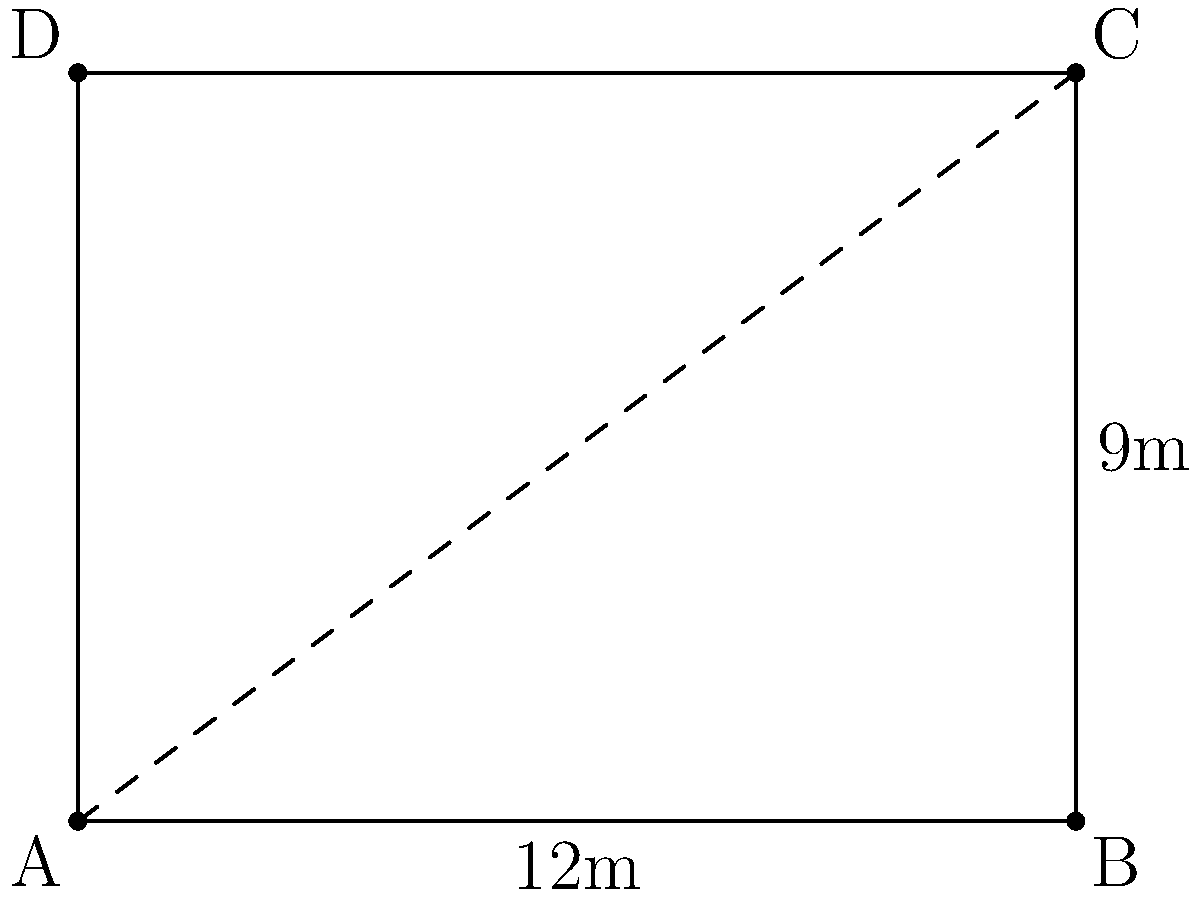In a rectangular dojo, two martial artists stand at opposite corners. The dojo measures 12 meters in length and 9 meters in width. What is the distance between the two martial artists? To find the distance between the two martial artists standing at opposite corners of the rectangular dojo, we can use the Pythagorean theorem. Let's approach this step-by-step:

1) The dojo forms a rectangle with length 12 meters and width 9 meters.

2) The distance between the opposite corners forms the hypotenuse of a right triangle.

3) Let's call this distance $d$. According to the Pythagorean theorem:

   $d^2 = 12^2 + 9^2$

4) Simplify the right side:
   $d^2 = 144 + 81 = 225$

5) Take the square root of both sides:
   $d = \sqrt{225}$

6) Simplify:
   $d = 15$

Therefore, the distance between the two martial artists is 15 meters.
Answer: 15 meters 